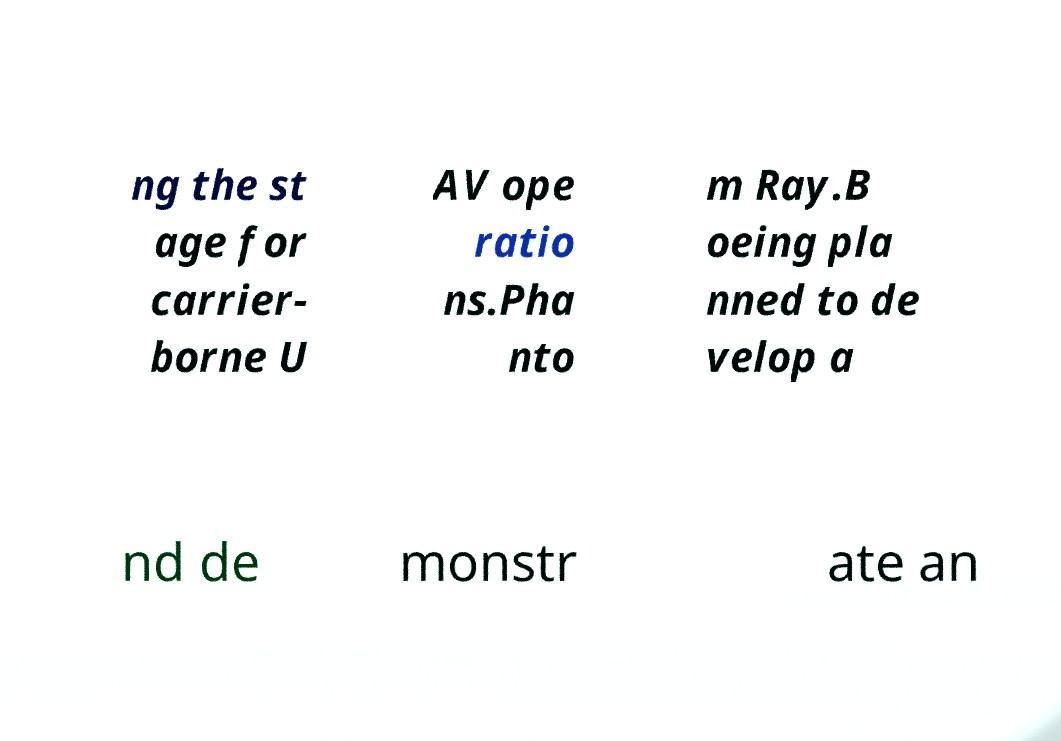Please identify and transcribe the text found in this image. ng the st age for carrier- borne U AV ope ratio ns.Pha nto m Ray.B oeing pla nned to de velop a nd de monstr ate an 